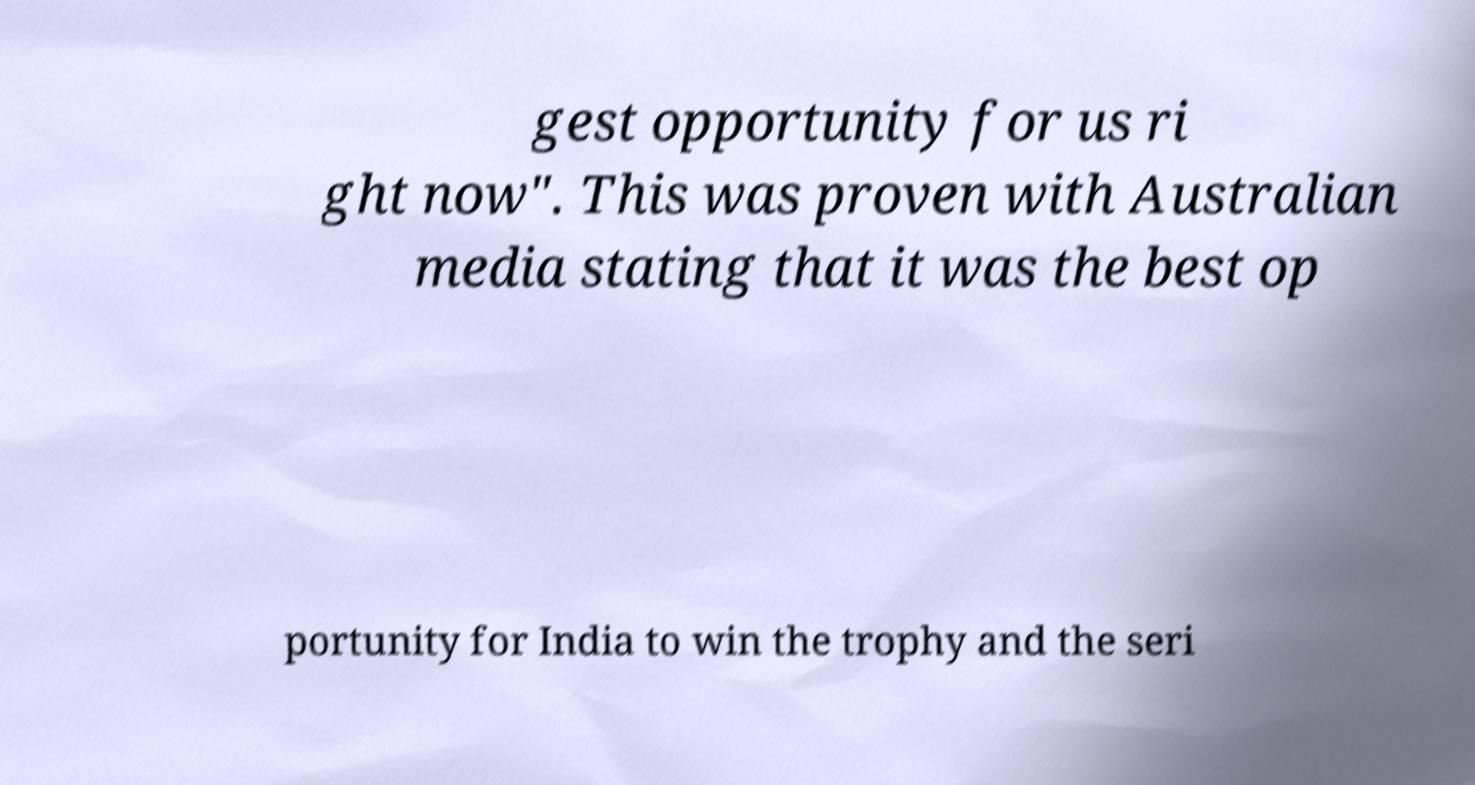Could you extract and type out the text from this image? gest opportunity for us ri ght now". This was proven with Australian media stating that it was the best op portunity for India to win the trophy and the seri 